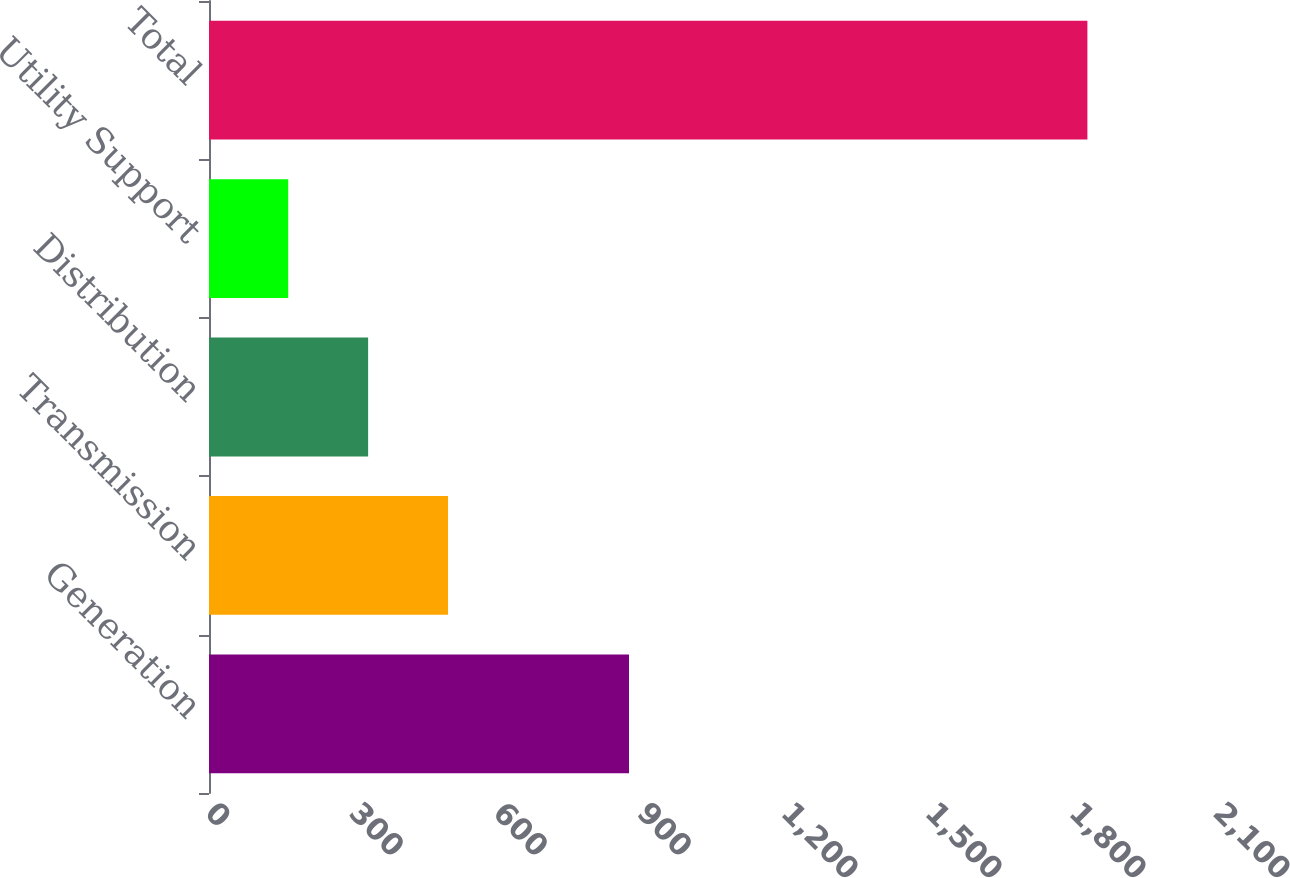Convert chart. <chart><loc_0><loc_0><loc_500><loc_500><bar_chart><fcel>Generation<fcel>Transmission<fcel>Distribution<fcel>Utility Support<fcel>Total<nl><fcel>875<fcel>498<fcel>331.5<fcel>165<fcel>1830<nl></chart> 